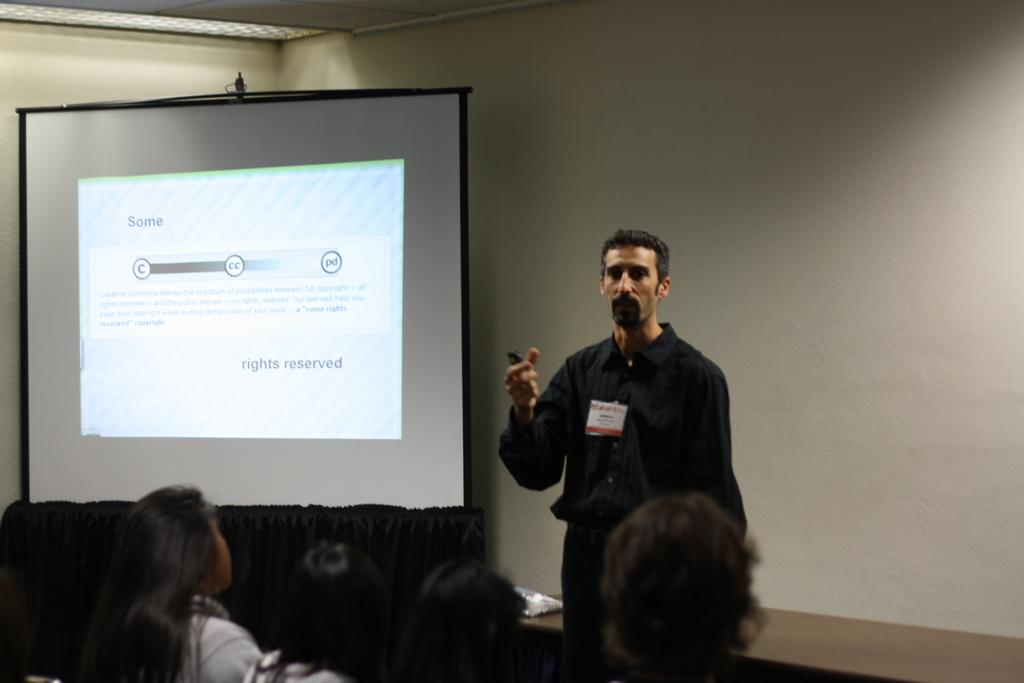What is the person in the image wearing? The person in the image is wearing a black dress. What is the standing person doing? The person is standing. What are the other persons in the image doing? The other persons are sitting in front of the standing person. What can be seen in the left corner of the image? There is a projected image in the left corner of the image. What type of flag is being waved by the geese in the image? There are no geese or flags present in the image. 